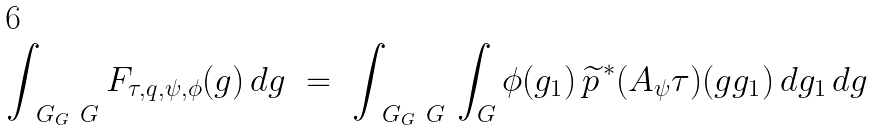Convert formula to latex. <formula><loc_0><loc_0><loc_500><loc_500>\int _ { \ G _ { G } \ G } F _ { \tau , q , \psi , \phi } ( g ) \, d g \ = \ \int _ { \ G _ { G } \ G } \, \int _ { G } \phi ( g _ { 1 } ) \, \widetilde { p } ^ { \, * } ( A _ { \psi } \tau ) ( g g _ { 1 } ) \, d g _ { 1 } \, d g</formula> 